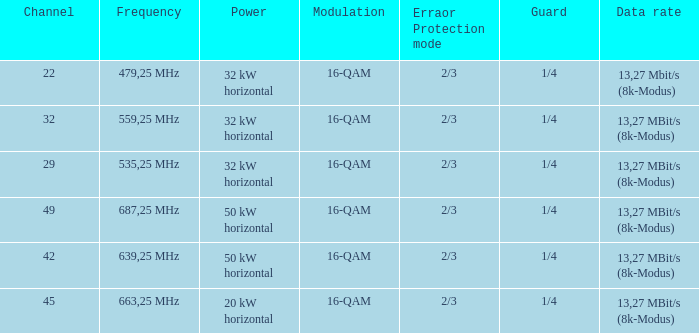On channel 32, when the power is 32 kW horizontal, what is the modulation? 16-QAM. 